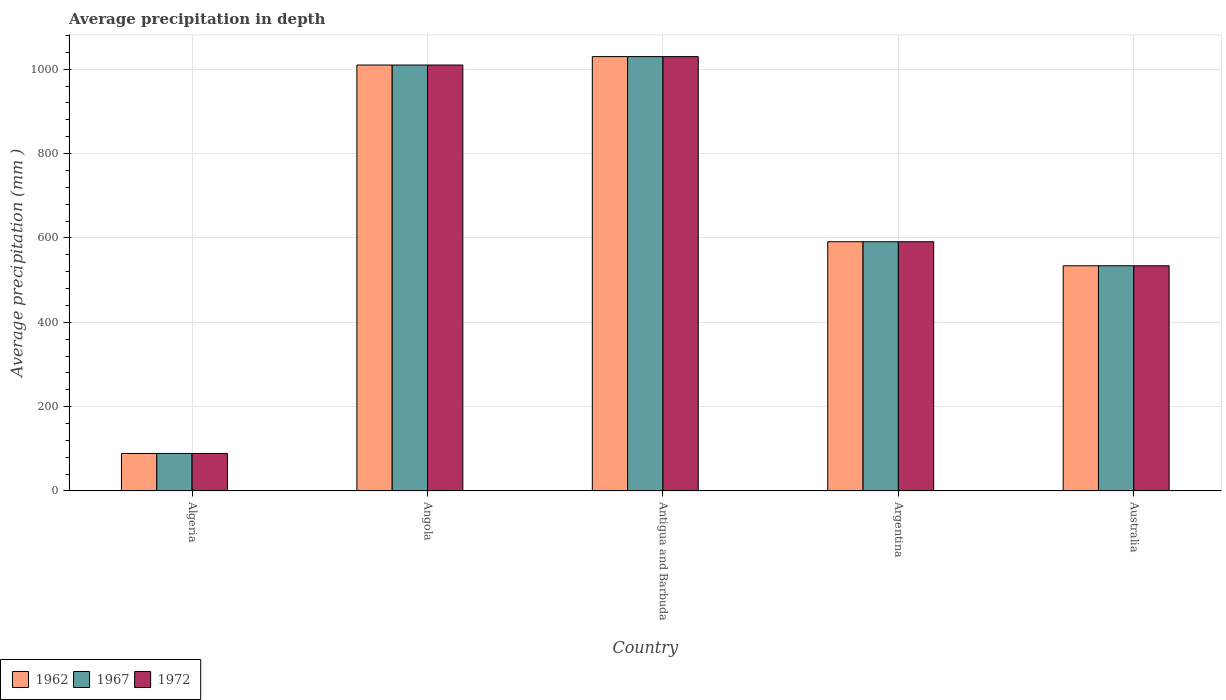How many bars are there on the 1st tick from the left?
Provide a short and direct response. 3. How many bars are there on the 3rd tick from the right?
Make the answer very short. 3. In how many cases, is the number of bars for a given country not equal to the number of legend labels?
Keep it short and to the point. 0. What is the average precipitation in 1972 in Antigua and Barbuda?
Your response must be concise. 1030. Across all countries, what is the maximum average precipitation in 1962?
Give a very brief answer. 1030. Across all countries, what is the minimum average precipitation in 1972?
Offer a terse response. 89. In which country was the average precipitation in 1972 maximum?
Your response must be concise. Antigua and Barbuda. In which country was the average precipitation in 1962 minimum?
Provide a short and direct response. Algeria. What is the total average precipitation in 1967 in the graph?
Provide a short and direct response. 3254. What is the difference between the average precipitation in 1972 in Antigua and Barbuda and that in Australia?
Offer a very short reply. 496. What is the difference between the average precipitation in 1967 in Antigua and Barbuda and the average precipitation in 1972 in Angola?
Ensure brevity in your answer.  20. What is the average average precipitation in 1967 per country?
Ensure brevity in your answer.  650.8. What is the difference between the average precipitation of/in 1962 and average precipitation of/in 1972 in Antigua and Barbuda?
Your answer should be compact. 0. In how many countries, is the average precipitation in 1972 greater than 320 mm?
Give a very brief answer. 4. What is the ratio of the average precipitation in 1972 in Angola to that in Argentina?
Your response must be concise. 1.71. Is the average precipitation in 1967 in Algeria less than that in Angola?
Keep it short and to the point. Yes. Is the difference between the average precipitation in 1962 in Angola and Antigua and Barbuda greater than the difference between the average precipitation in 1972 in Angola and Antigua and Barbuda?
Your response must be concise. No. What is the difference between the highest and the lowest average precipitation in 1967?
Offer a very short reply. 941. In how many countries, is the average precipitation in 1962 greater than the average average precipitation in 1962 taken over all countries?
Make the answer very short. 2. What does the 2nd bar from the left in Algeria represents?
Make the answer very short. 1967. Does the graph contain grids?
Offer a very short reply. Yes. Where does the legend appear in the graph?
Provide a short and direct response. Bottom left. What is the title of the graph?
Give a very brief answer. Average precipitation in depth. What is the label or title of the Y-axis?
Your answer should be compact. Average precipitation (mm ). What is the Average precipitation (mm ) in 1962 in Algeria?
Ensure brevity in your answer.  89. What is the Average precipitation (mm ) in 1967 in Algeria?
Give a very brief answer. 89. What is the Average precipitation (mm ) in 1972 in Algeria?
Your response must be concise. 89. What is the Average precipitation (mm ) in 1962 in Angola?
Keep it short and to the point. 1010. What is the Average precipitation (mm ) in 1967 in Angola?
Your answer should be compact. 1010. What is the Average precipitation (mm ) of 1972 in Angola?
Your answer should be compact. 1010. What is the Average precipitation (mm ) of 1962 in Antigua and Barbuda?
Your answer should be compact. 1030. What is the Average precipitation (mm ) of 1967 in Antigua and Barbuda?
Provide a short and direct response. 1030. What is the Average precipitation (mm ) in 1972 in Antigua and Barbuda?
Your response must be concise. 1030. What is the Average precipitation (mm ) in 1962 in Argentina?
Make the answer very short. 591. What is the Average precipitation (mm ) in 1967 in Argentina?
Keep it short and to the point. 591. What is the Average precipitation (mm ) in 1972 in Argentina?
Offer a very short reply. 591. What is the Average precipitation (mm ) of 1962 in Australia?
Offer a terse response. 534. What is the Average precipitation (mm ) in 1967 in Australia?
Provide a succinct answer. 534. What is the Average precipitation (mm ) of 1972 in Australia?
Keep it short and to the point. 534. Across all countries, what is the maximum Average precipitation (mm ) in 1962?
Provide a succinct answer. 1030. Across all countries, what is the maximum Average precipitation (mm ) in 1967?
Provide a succinct answer. 1030. Across all countries, what is the maximum Average precipitation (mm ) of 1972?
Ensure brevity in your answer.  1030. Across all countries, what is the minimum Average precipitation (mm ) in 1962?
Offer a very short reply. 89. Across all countries, what is the minimum Average precipitation (mm ) of 1967?
Give a very brief answer. 89. Across all countries, what is the minimum Average precipitation (mm ) of 1972?
Keep it short and to the point. 89. What is the total Average precipitation (mm ) of 1962 in the graph?
Keep it short and to the point. 3254. What is the total Average precipitation (mm ) in 1967 in the graph?
Ensure brevity in your answer.  3254. What is the total Average precipitation (mm ) of 1972 in the graph?
Your response must be concise. 3254. What is the difference between the Average precipitation (mm ) of 1962 in Algeria and that in Angola?
Keep it short and to the point. -921. What is the difference between the Average precipitation (mm ) of 1967 in Algeria and that in Angola?
Provide a short and direct response. -921. What is the difference between the Average precipitation (mm ) of 1972 in Algeria and that in Angola?
Offer a terse response. -921. What is the difference between the Average precipitation (mm ) of 1962 in Algeria and that in Antigua and Barbuda?
Keep it short and to the point. -941. What is the difference between the Average precipitation (mm ) of 1967 in Algeria and that in Antigua and Barbuda?
Provide a succinct answer. -941. What is the difference between the Average precipitation (mm ) of 1972 in Algeria and that in Antigua and Barbuda?
Make the answer very short. -941. What is the difference between the Average precipitation (mm ) of 1962 in Algeria and that in Argentina?
Keep it short and to the point. -502. What is the difference between the Average precipitation (mm ) in 1967 in Algeria and that in Argentina?
Provide a succinct answer. -502. What is the difference between the Average precipitation (mm ) of 1972 in Algeria and that in Argentina?
Offer a terse response. -502. What is the difference between the Average precipitation (mm ) in 1962 in Algeria and that in Australia?
Ensure brevity in your answer.  -445. What is the difference between the Average precipitation (mm ) in 1967 in Algeria and that in Australia?
Provide a short and direct response. -445. What is the difference between the Average precipitation (mm ) of 1972 in Algeria and that in Australia?
Keep it short and to the point. -445. What is the difference between the Average precipitation (mm ) of 1967 in Angola and that in Antigua and Barbuda?
Keep it short and to the point. -20. What is the difference between the Average precipitation (mm ) in 1962 in Angola and that in Argentina?
Keep it short and to the point. 419. What is the difference between the Average precipitation (mm ) of 1967 in Angola and that in Argentina?
Provide a short and direct response. 419. What is the difference between the Average precipitation (mm ) in 1972 in Angola and that in Argentina?
Your answer should be compact. 419. What is the difference between the Average precipitation (mm ) of 1962 in Angola and that in Australia?
Your response must be concise. 476. What is the difference between the Average precipitation (mm ) in 1967 in Angola and that in Australia?
Your answer should be very brief. 476. What is the difference between the Average precipitation (mm ) of 1972 in Angola and that in Australia?
Give a very brief answer. 476. What is the difference between the Average precipitation (mm ) of 1962 in Antigua and Barbuda and that in Argentina?
Ensure brevity in your answer.  439. What is the difference between the Average precipitation (mm ) in 1967 in Antigua and Barbuda and that in Argentina?
Your answer should be very brief. 439. What is the difference between the Average precipitation (mm ) of 1972 in Antigua and Barbuda and that in Argentina?
Your answer should be compact. 439. What is the difference between the Average precipitation (mm ) in 1962 in Antigua and Barbuda and that in Australia?
Provide a short and direct response. 496. What is the difference between the Average precipitation (mm ) in 1967 in Antigua and Barbuda and that in Australia?
Ensure brevity in your answer.  496. What is the difference between the Average precipitation (mm ) of 1972 in Antigua and Barbuda and that in Australia?
Offer a terse response. 496. What is the difference between the Average precipitation (mm ) of 1962 in Argentina and that in Australia?
Your response must be concise. 57. What is the difference between the Average precipitation (mm ) in 1967 in Argentina and that in Australia?
Give a very brief answer. 57. What is the difference between the Average precipitation (mm ) in 1962 in Algeria and the Average precipitation (mm ) in 1967 in Angola?
Make the answer very short. -921. What is the difference between the Average precipitation (mm ) of 1962 in Algeria and the Average precipitation (mm ) of 1972 in Angola?
Keep it short and to the point. -921. What is the difference between the Average precipitation (mm ) in 1967 in Algeria and the Average precipitation (mm ) in 1972 in Angola?
Your answer should be compact. -921. What is the difference between the Average precipitation (mm ) of 1962 in Algeria and the Average precipitation (mm ) of 1967 in Antigua and Barbuda?
Offer a terse response. -941. What is the difference between the Average precipitation (mm ) in 1962 in Algeria and the Average precipitation (mm ) in 1972 in Antigua and Barbuda?
Make the answer very short. -941. What is the difference between the Average precipitation (mm ) in 1967 in Algeria and the Average precipitation (mm ) in 1972 in Antigua and Barbuda?
Provide a short and direct response. -941. What is the difference between the Average precipitation (mm ) in 1962 in Algeria and the Average precipitation (mm ) in 1967 in Argentina?
Keep it short and to the point. -502. What is the difference between the Average precipitation (mm ) in 1962 in Algeria and the Average precipitation (mm ) in 1972 in Argentina?
Provide a short and direct response. -502. What is the difference between the Average precipitation (mm ) of 1967 in Algeria and the Average precipitation (mm ) of 1972 in Argentina?
Offer a very short reply. -502. What is the difference between the Average precipitation (mm ) of 1962 in Algeria and the Average precipitation (mm ) of 1967 in Australia?
Ensure brevity in your answer.  -445. What is the difference between the Average precipitation (mm ) in 1962 in Algeria and the Average precipitation (mm ) in 1972 in Australia?
Your answer should be very brief. -445. What is the difference between the Average precipitation (mm ) in 1967 in Algeria and the Average precipitation (mm ) in 1972 in Australia?
Offer a very short reply. -445. What is the difference between the Average precipitation (mm ) in 1962 in Angola and the Average precipitation (mm ) in 1967 in Argentina?
Your answer should be compact. 419. What is the difference between the Average precipitation (mm ) in 1962 in Angola and the Average precipitation (mm ) in 1972 in Argentina?
Provide a short and direct response. 419. What is the difference between the Average precipitation (mm ) in 1967 in Angola and the Average precipitation (mm ) in 1972 in Argentina?
Ensure brevity in your answer.  419. What is the difference between the Average precipitation (mm ) of 1962 in Angola and the Average precipitation (mm ) of 1967 in Australia?
Give a very brief answer. 476. What is the difference between the Average precipitation (mm ) in 1962 in Angola and the Average precipitation (mm ) in 1972 in Australia?
Your answer should be compact. 476. What is the difference between the Average precipitation (mm ) in 1967 in Angola and the Average precipitation (mm ) in 1972 in Australia?
Provide a succinct answer. 476. What is the difference between the Average precipitation (mm ) in 1962 in Antigua and Barbuda and the Average precipitation (mm ) in 1967 in Argentina?
Make the answer very short. 439. What is the difference between the Average precipitation (mm ) in 1962 in Antigua and Barbuda and the Average precipitation (mm ) in 1972 in Argentina?
Your response must be concise. 439. What is the difference between the Average precipitation (mm ) in 1967 in Antigua and Barbuda and the Average precipitation (mm ) in 1972 in Argentina?
Your answer should be very brief. 439. What is the difference between the Average precipitation (mm ) of 1962 in Antigua and Barbuda and the Average precipitation (mm ) of 1967 in Australia?
Make the answer very short. 496. What is the difference between the Average precipitation (mm ) of 1962 in Antigua and Barbuda and the Average precipitation (mm ) of 1972 in Australia?
Keep it short and to the point. 496. What is the difference between the Average precipitation (mm ) in 1967 in Antigua and Barbuda and the Average precipitation (mm ) in 1972 in Australia?
Ensure brevity in your answer.  496. What is the average Average precipitation (mm ) in 1962 per country?
Your answer should be compact. 650.8. What is the average Average precipitation (mm ) of 1967 per country?
Your answer should be compact. 650.8. What is the average Average precipitation (mm ) of 1972 per country?
Ensure brevity in your answer.  650.8. What is the difference between the Average precipitation (mm ) of 1962 and Average precipitation (mm ) of 1967 in Algeria?
Provide a short and direct response. 0. What is the difference between the Average precipitation (mm ) in 1962 and Average precipitation (mm ) in 1972 in Algeria?
Your response must be concise. 0. What is the difference between the Average precipitation (mm ) of 1967 and Average precipitation (mm ) of 1972 in Algeria?
Your answer should be very brief. 0. What is the difference between the Average precipitation (mm ) in 1967 and Average precipitation (mm ) in 1972 in Angola?
Your response must be concise. 0. What is the difference between the Average precipitation (mm ) of 1962 and Average precipitation (mm ) of 1972 in Argentina?
Keep it short and to the point. 0. What is the difference between the Average precipitation (mm ) of 1967 and Average precipitation (mm ) of 1972 in Argentina?
Ensure brevity in your answer.  0. What is the difference between the Average precipitation (mm ) in 1962 and Average precipitation (mm ) in 1967 in Australia?
Your answer should be very brief. 0. What is the ratio of the Average precipitation (mm ) of 1962 in Algeria to that in Angola?
Provide a short and direct response. 0.09. What is the ratio of the Average precipitation (mm ) in 1967 in Algeria to that in Angola?
Keep it short and to the point. 0.09. What is the ratio of the Average precipitation (mm ) of 1972 in Algeria to that in Angola?
Your answer should be very brief. 0.09. What is the ratio of the Average precipitation (mm ) of 1962 in Algeria to that in Antigua and Barbuda?
Make the answer very short. 0.09. What is the ratio of the Average precipitation (mm ) in 1967 in Algeria to that in Antigua and Barbuda?
Provide a short and direct response. 0.09. What is the ratio of the Average precipitation (mm ) in 1972 in Algeria to that in Antigua and Barbuda?
Provide a succinct answer. 0.09. What is the ratio of the Average precipitation (mm ) of 1962 in Algeria to that in Argentina?
Give a very brief answer. 0.15. What is the ratio of the Average precipitation (mm ) of 1967 in Algeria to that in Argentina?
Offer a very short reply. 0.15. What is the ratio of the Average precipitation (mm ) of 1972 in Algeria to that in Argentina?
Provide a short and direct response. 0.15. What is the ratio of the Average precipitation (mm ) in 1962 in Algeria to that in Australia?
Offer a very short reply. 0.17. What is the ratio of the Average precipitation (mm ) of 1962 in Angola to that in Antigua and Barbuda?
Keep it short and to the point. 0.98. What is the ratio of the Average precipitation (mm ) in 1967 in Angola to that in Antigua and Barbuda?
Your response must be concise. 0.98. What is the ratio of the Average precipitation (mm ) in 1972 in Angola to that in Antigua and Barbuda?
Ensure brevity in your answer.  0.98. What is the ratio of the Average precipitation (mm ) in 1962 in Angola to that in Argentina?
Keep it short and to the point. 1.71. What is the ratio of the Average precipitation (mm ) in 1967 in Angola to that in Argentina?
Your answer should be compact. 1.71. What is the ratio of the Average precipitation (mm ) of 1972 in Angola to that in Argentina?
Give a very brief answer. 1.71. What is the ratio of the Average precipitation (mm ) of 1962 in Angola to that in Australia?
Ensure brevity in your answer.  1.89. What is the ratio of the Average precipitation (mm ) of 1967 in Angola to that in Australia?
Your answer should be compact. 1.89. What is the ratio of the Average precipitation (mm ) in 1972 in Angola to that in Australia?
Offer a very short reply. 1.89. What is the ratio of the Average precipitation (mm ) in 1962 in Antigua and Barbuda to that in Argentina?
Make the answer very short. 1.74. What is the ratio of the Average precipitation (mm ) of 1967 in Antigua and Barbuda to that in Argentina?
Provide a succinct answer. 1.74. What is the ratio of the Average precipitation (mm ) in 1972 in Antigua and Barbuda to that in Argentina?
Keep it short and to the point. 1.74. What is the ratio of the Average precipitation (mm ) of 1962 in Antigua and Barbuda to that in Australia?
Give a very brief answer. 1.93. What is the ratio of the Average precipitation (mm ) in 1967 in Antigua and Barbuda to that in Australia?
Keep it short and to the point. 1.93. What is the ratio of the Average precipitation (mm ) of 1972 in Antigua and Barbuda to that in Australia?
Make the answer very short. 1.93. What is the ratio of the Average precipitation (mm ) of 1962 in Argentina to that in Australia?
Ensure brevity in your answer.  1.11. What is the ratio of the Average precipitation (mm ) of 1967 in Argentina to that in Australia?
Provide a short and direct response. 1.11. What is the ratio of the Average precipitation (mm ) of 1972 in Argentina to that in Australia?
Keep it short and to the point. 1.11. What is the difference between the highest and the second highest Average precipitation (mm ) of 1967?
Your response must be concise. 20. What is the difference between the highest and the second highest Average precipitation (mm ) of 1972?
Provide a succinct answer. 20. What is the difference between the highest and the lowest Average precipitation (mm ) in 1962?
Provide a short and direct response. 941. What is the difference between the highest and the lowest Average precipitation (mm ) in 1967?
Make the answer very short. 941. What is the difference between the highest and the lowest Average precipitation (mm ) of 1972?
Give a very brief answer. 941. 